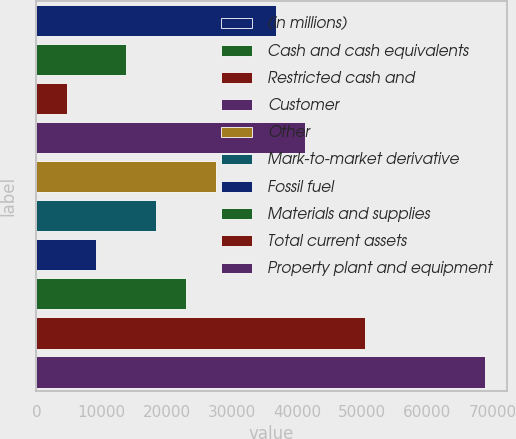Convert chart. <chart><loc_0><loc_0><loc_500><loc_500><bar_chart><fcel>(in millions)<fcel>Cash and cash equivalents<fcel>Restricted cash and<fcel>Customer<fcel>Other<fcel>Mark-to-market derivative<fcel>Fossil fuel<fcel>Materials and supplies<fcel>Total current assets<fcel>Property plant and equipment<nl><fcel>36727.8<fcel>13812.3<fcel>4646.1<fcel>41310.9<fcel>27561.6<fcel>18395.4<fcel>9229.2<fcel>22978.5<fcel>50477.1<fcel>68809.5<nl></chart> 